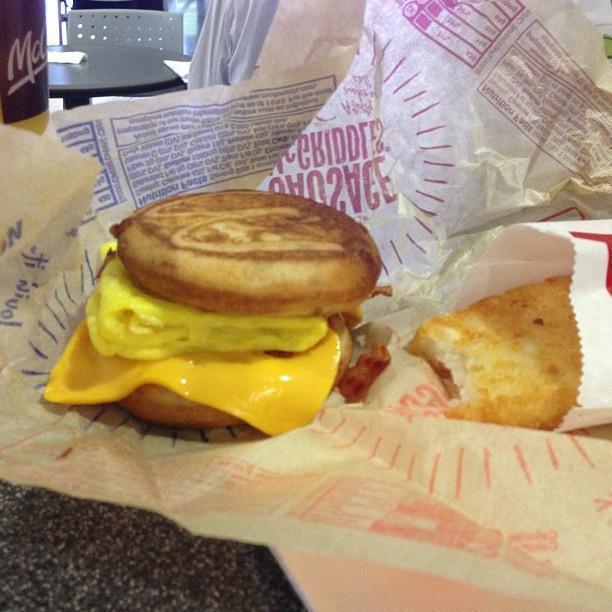What is the yellow item near the egg?
Choose the right answer and clarify with the format: 'Answer: answer
Rationale: rationale.'
Options: Corn muffin, cheese, canary, lemon. Answer: cheese.
Rationale: American cheese is yellow and melts. 